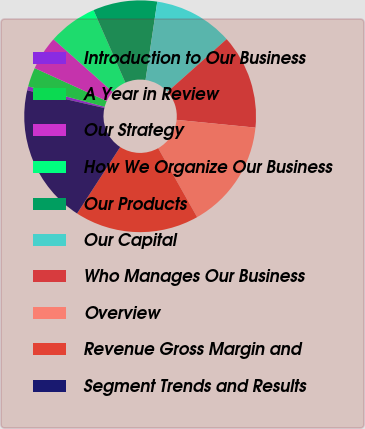<chart> <loc_0><loc_0><loc_500><loc_500><pie_chart><fcel>Introduction to Our Business<fcel>A Year in Review<fcel>Our Strategy<fcel>How We Organize Our Business<fcel>Our Products<fcel>Our Capital<fcel>Who Manages Our Business<fcel>Overview<fcel>Revenue Gross Margin and<fcel>Segment Trends and Results<nl><fcel>0.56%<fcel>2.66%<fcel>4.75%<fcel>6.85%<fcel>8.95%<fcel>11.05%<fcel>13.15%<fcel>15.25%<fcel>17.34%<fcel>19.44%<nl></chart> 